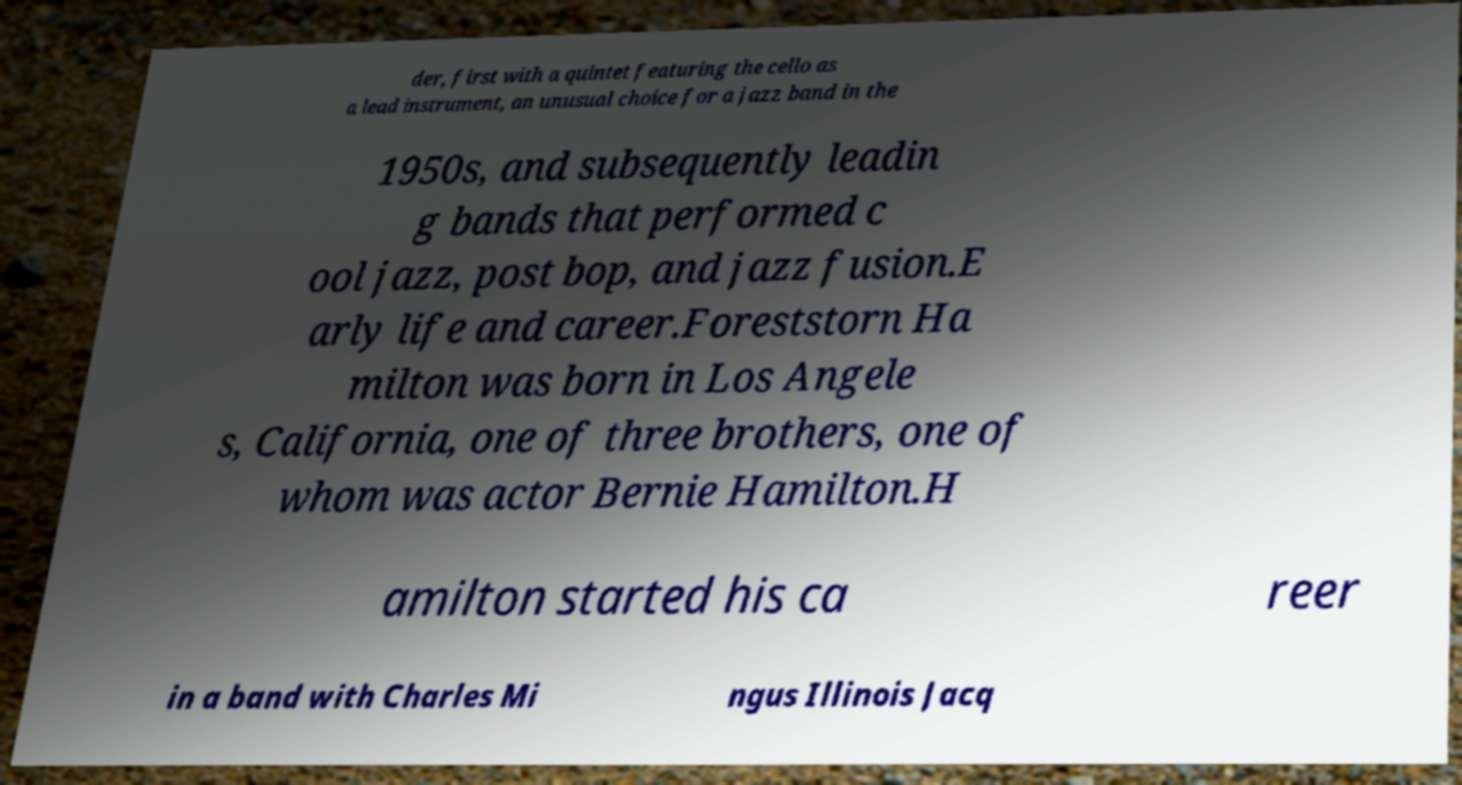There's text embedded in this image that I need extracted. Can you transcribe it verbatim? der, first with a quintet featuring the cello as a lead instrument, an unusual choice for a jazz band in the 1950s, and subsequently leadin g bands that performed c ool jazz, post bop, and jazz fusion.E arly life and career.Foreststorn Ha milton was born in Los Angele s, California, one of three brothers, one of whom was actor Bernie Hamilton.H amilton started his ca reer in a band with Charles Mi ngus Illinois Jacq 